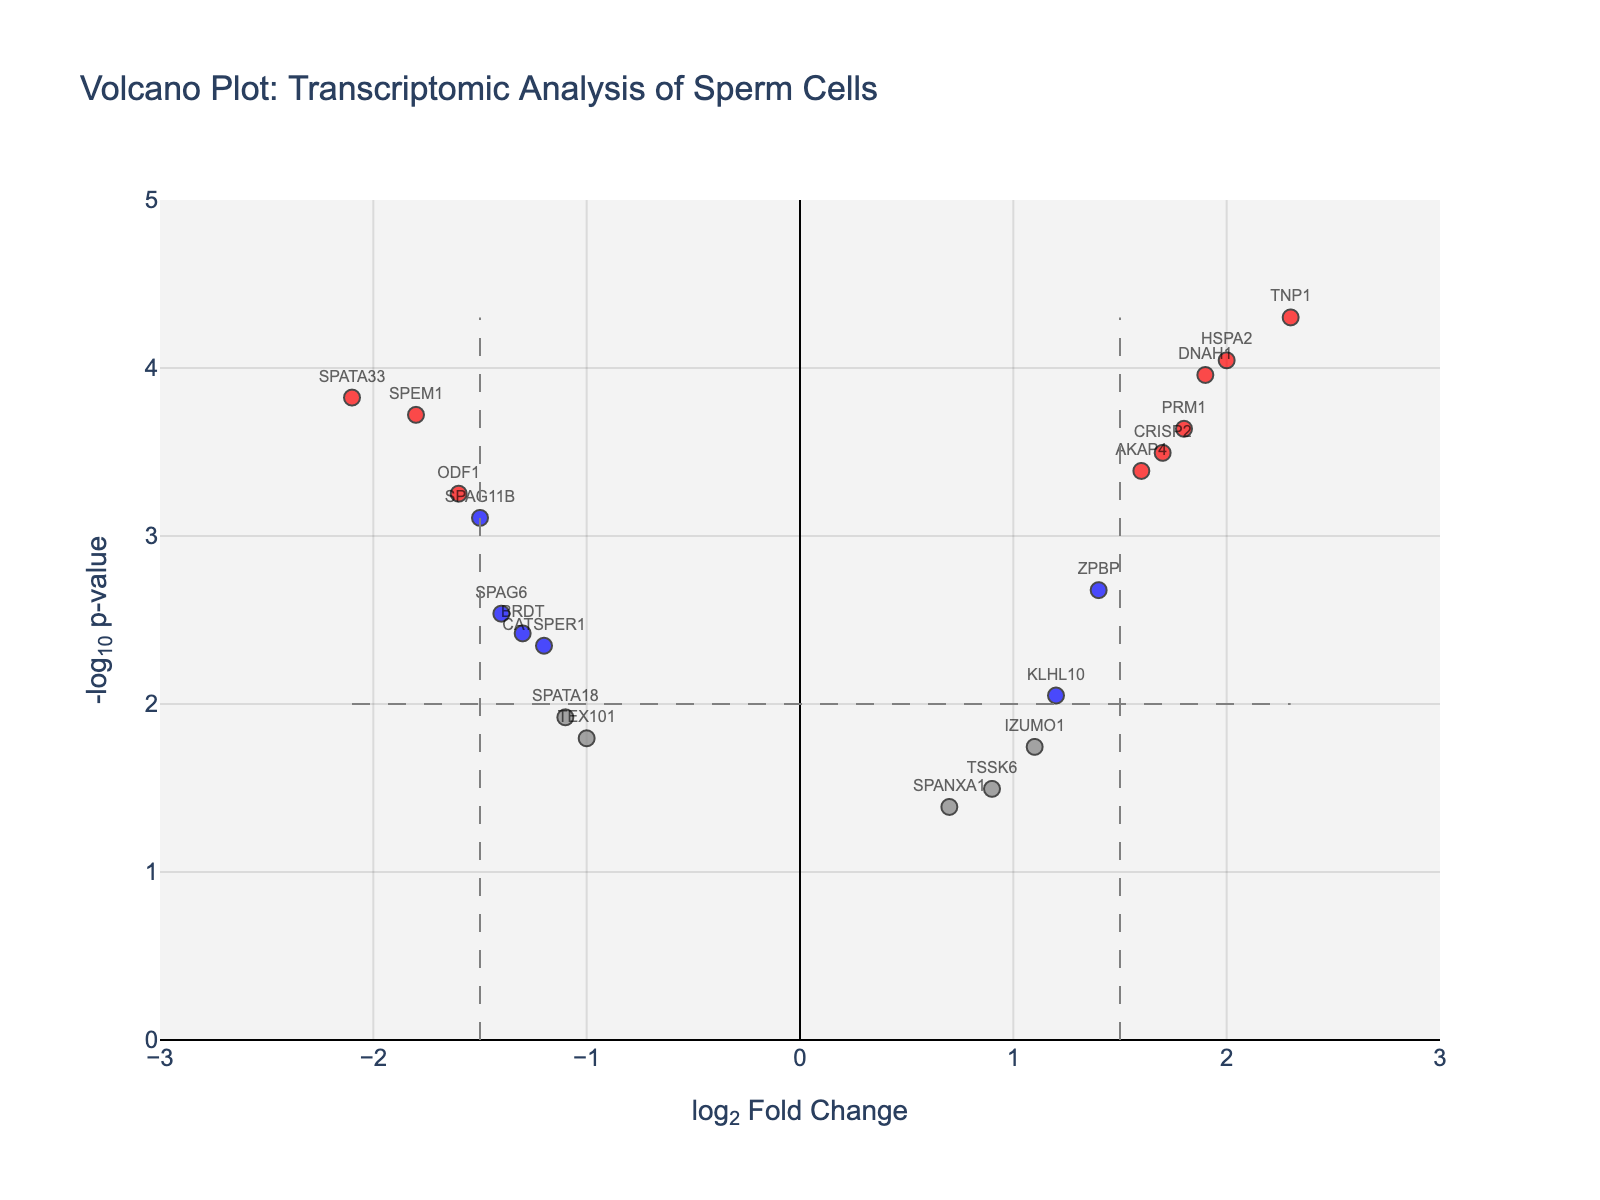What's the title of the figure? The title is found at the top center of the plot. In this case, it is clearly labeled above the main plot area.
Answer: "Volcano Plot: Transcriptomic Analysis of Sperm Cells" What are the labels on the x-axis and y-axis? The labels are present along the axes; the x-axis describes the log fold change, and the y-axis describes the negative log p-value.
Answer: x-axis: log2 Fold Change, y-axis: -log10 p-value How many genes are significantly differentially expressed with a log2 fold change greater than 1.5 and a p-value less than 0.01? Significant genes are colored red and positioned either to the left or right of the central clumping of grey, blue, or green points, falling outside specific thresholds.
Answer: 4 Identify any data points that have a log2 fold change less than -2.0 with a significant p-value. A log2 fold change less than -2.0 places these data points on the leftmost side of the plot below the threshold. Look for values in the significant red designated area.
Answer: SPATA33 Which gene has the highest negative log p-value and what is its log2 fold change? The gene with the highest negative log p-value will be at the topmost point of the plot. Check its log2 fold change using the horizontal position.
Answer: TNP1, log2FC: 2.3 Is there a gene with a log2 fold change around 1.0 and a significant p-value? Look along the x-axis for log2 fold changes around 1.0, and check the color/geonlegend to categorize it (blue/red if significant).
Answer: TSSK6, IZUMO1 What is the log2 fold change range shown on the x-axis? The range of log2 fold change is indicated by the limits of the x-axis. This can visually be identified from the start to the ending point along the x-axis.
Answer: -3 to 3 Compare the positions of PRM1 and TNP1 genes in the plot. Which one has a higher negative log p-value and by how much? Find the vertical positions of both data points and calculate their difference in y-values.
Answer: TNP1 has a higher negative log p-value by approximately 1.2 How many data points are colored blue, indicating significant but not highly fold-changed genes? Blue points are within the limits of x-axis fold change thresholds but below significant p-value thresholds, thus located towards the middle top portion.
Answer: 8 Are there any genes with a log2 fold change close to zero but still significant? Look for data points near zero on the x-axis but are colored red or blue, indicating significance.
Answer: None 